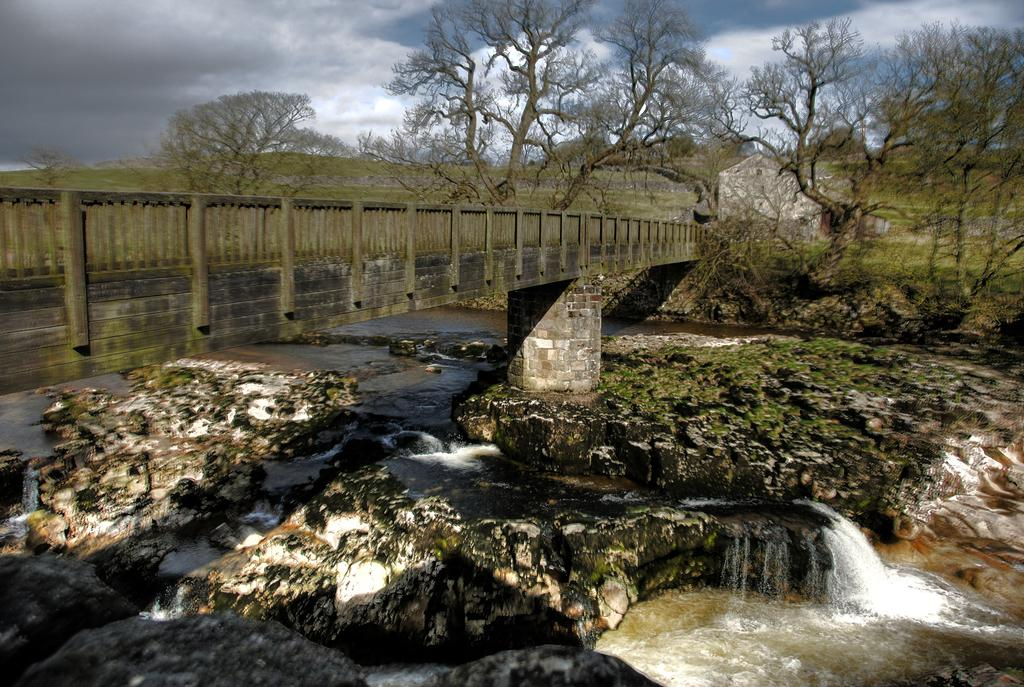What structure is located on the left side of the image? There is a bridge on the left side of the image. What is happening in the middle of the image? Water is flowing in the image. What type of vegetation is on the right side of the image? There are trees on the right side of the image. Can you see a crayon being used to draw on the bridge in the image? There is no crayon or drawing activity present in the image. Are there any monkeys visible in the trees on the right side of the image? There are no monkeys present in the image; only trees are visible. 